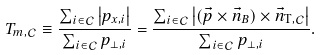Convert formula to latex. <formula><loc_0><loc_0><loc_500><loc_500>T _ { m , \mathcal { C } } \equiv \frac { \sum _ { i \in \mathcal { C } } \left | { p } _ { x , i } \right | } { \sum _ { i \in \mathcal { C } } p _ { \perp , i } } = \frac { \sum _ { i \in \mathcal { C } } \left | ( \vec { p } \times \vec { n } _ { B } ) \times \vec { n } _ { \text {T} , \mathcal { C } } \right | } { \sum _ { i \in \mathcal { C } } p _ { \perp , i } } .</formula> 